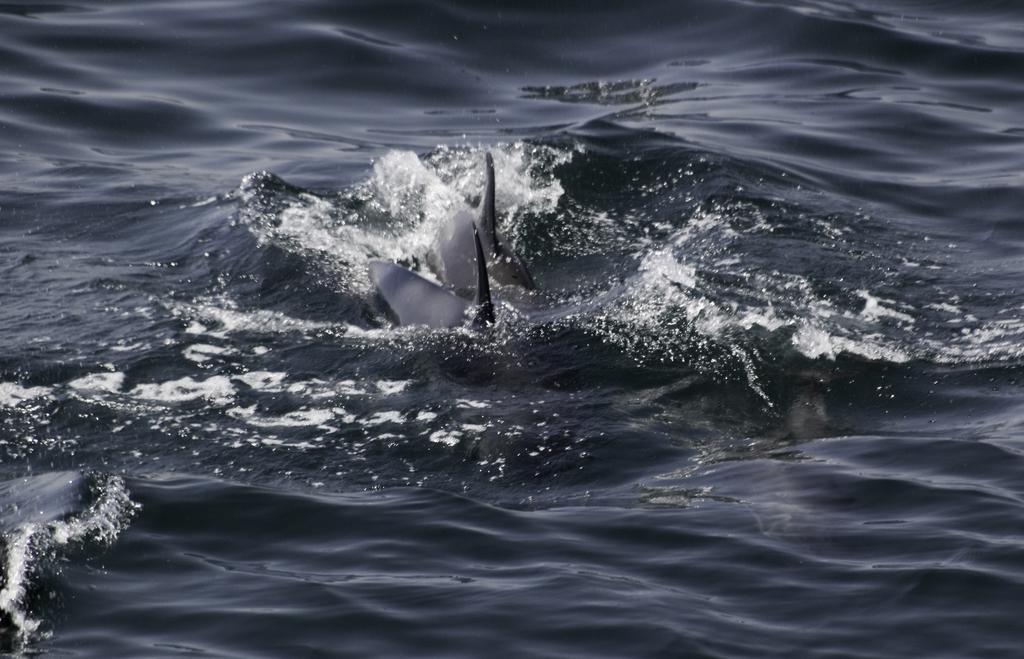In one or two sentences, can you explain what this image depicts? This image is taken outdoors. At the bottom of the image there is a sea. In the middle of the image there are two sharks in the sea. 